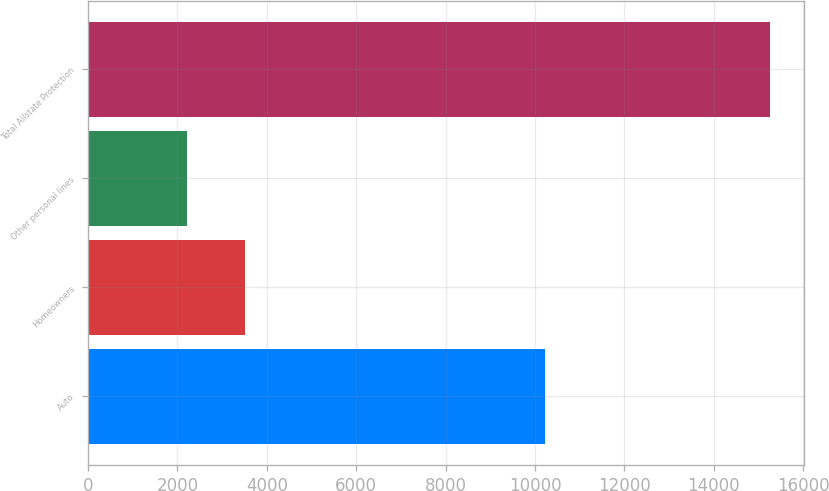<chart> <loc_0><loc_0><loc_500><loc_500><bar_chart><fcel>Auto<fcel>Homeowners<fcel>Other personal lines<fcel>Total Allstate Protection<nl><fcel>10220<fcel>3511.4<fcel>2207<fcel>15251<nl></chart> 